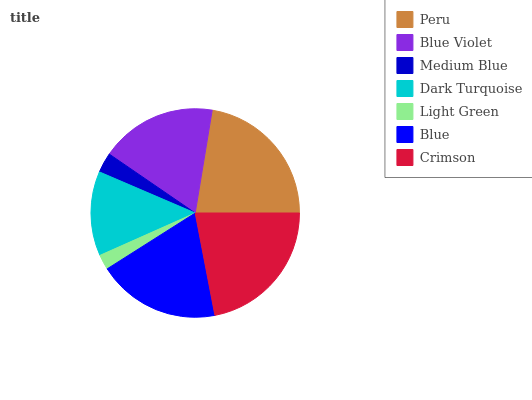Is Light Green the minimum?
Answer yes or no. Yes. Is Peru the maximum?
Answer yes or no. Yes. Is Blue Violet the minimum?
Answer yes or no. No. Is Blue Violet the maximum?
Answer yes or no. No. Is Peru greater than Blue Violet?
Answer yes or no. Yes. Is Blue Violet less than Peru?
Answer yes or no. Yes. Is Blue Violet greater than Peru?
Answer yes or no. No. Is Peru less than Blue Violet?
Answer yes or no. No. Is Blue Violet the high median?
Answer yes or no. Yes. Is Blue Violet the low median?
Answer yes or no. Yes. Is Crimson the high median?
Answer yes or no. No. Is Peru the low median?
Answer yes or no. No. 